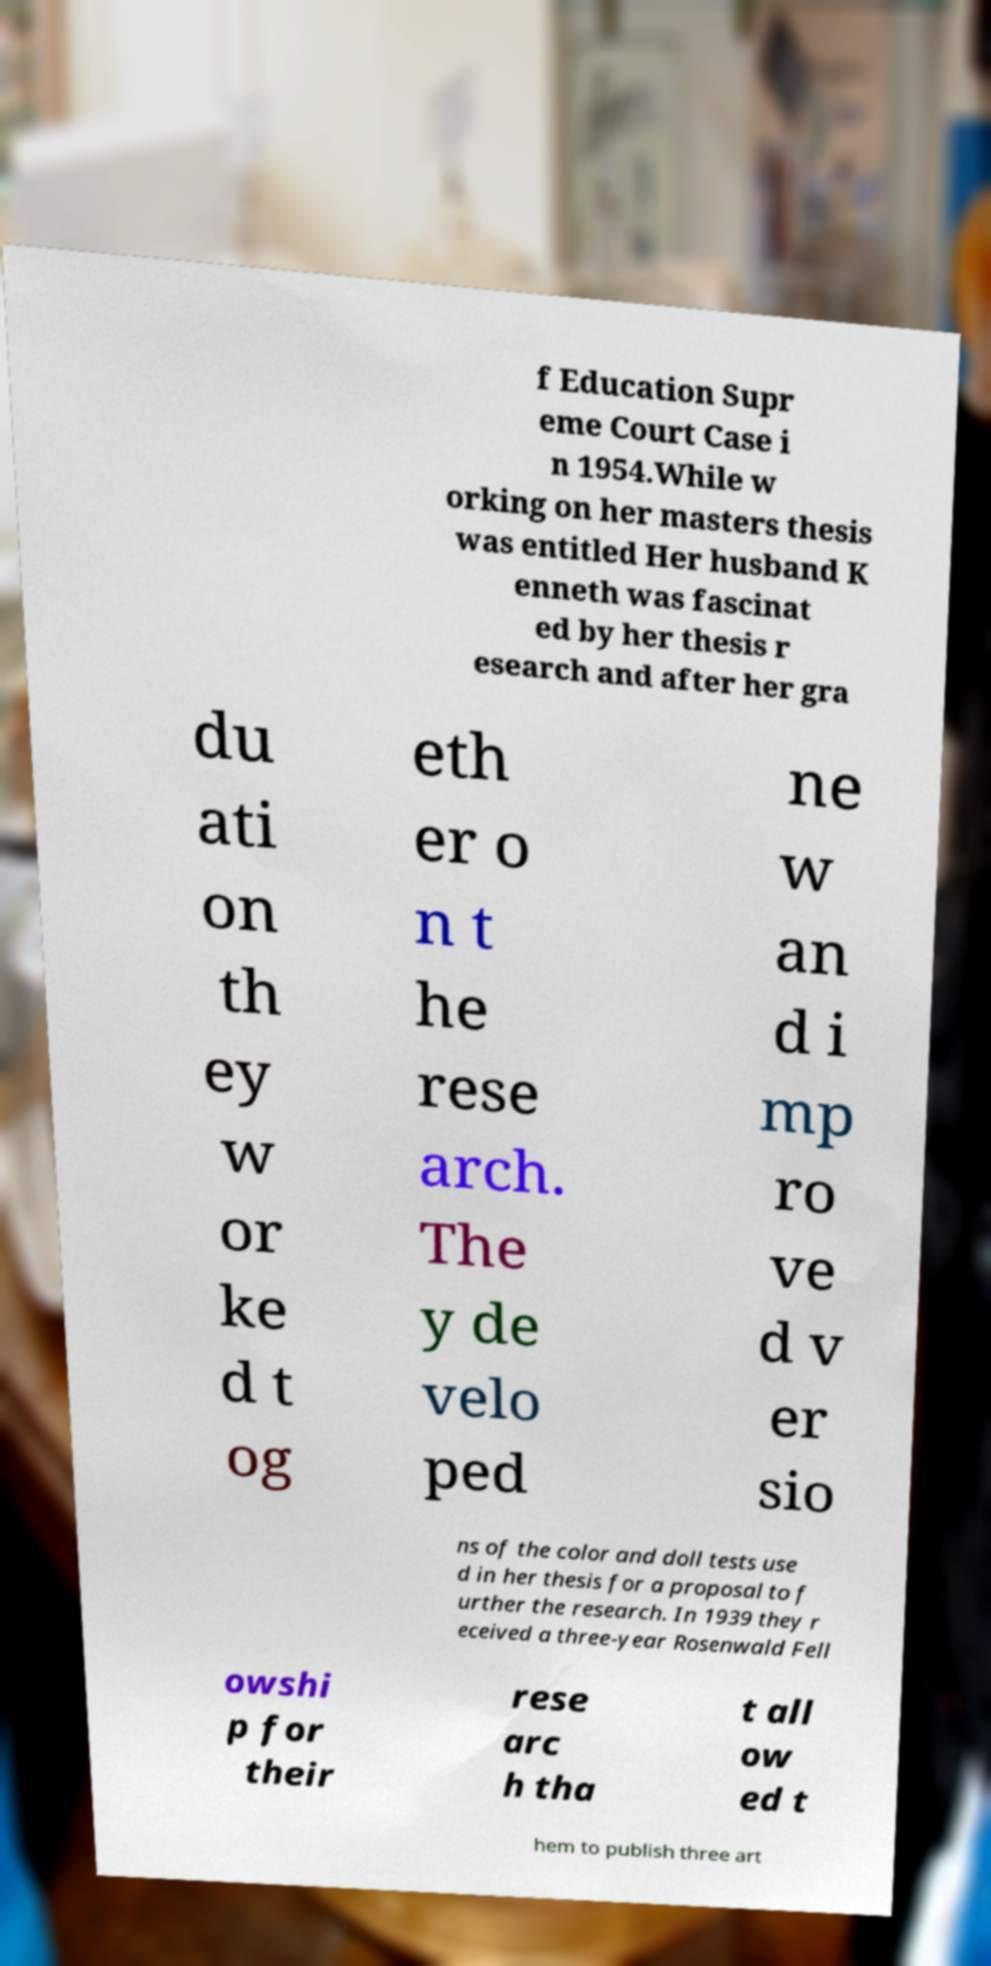Could you extract and type out the text from this image? f Education Supr eme Court Case i n 1954.While w orking on her masters thesis was entitled Her husband K enneth was fascinat ed by her thesis r esearch and after her gra du ati on th ey w or ke d t og eth er o n t he rese arch. The y de velo ped ne w an d i mp ro ve d v er sio ns of the color and doll tests use d in her thesis for a proposal to f urther the research. In 1939 they r eceived a three-year Rosenwald Fell owshi p for their rese arc h tha t all ow ed t hem to publish three art 